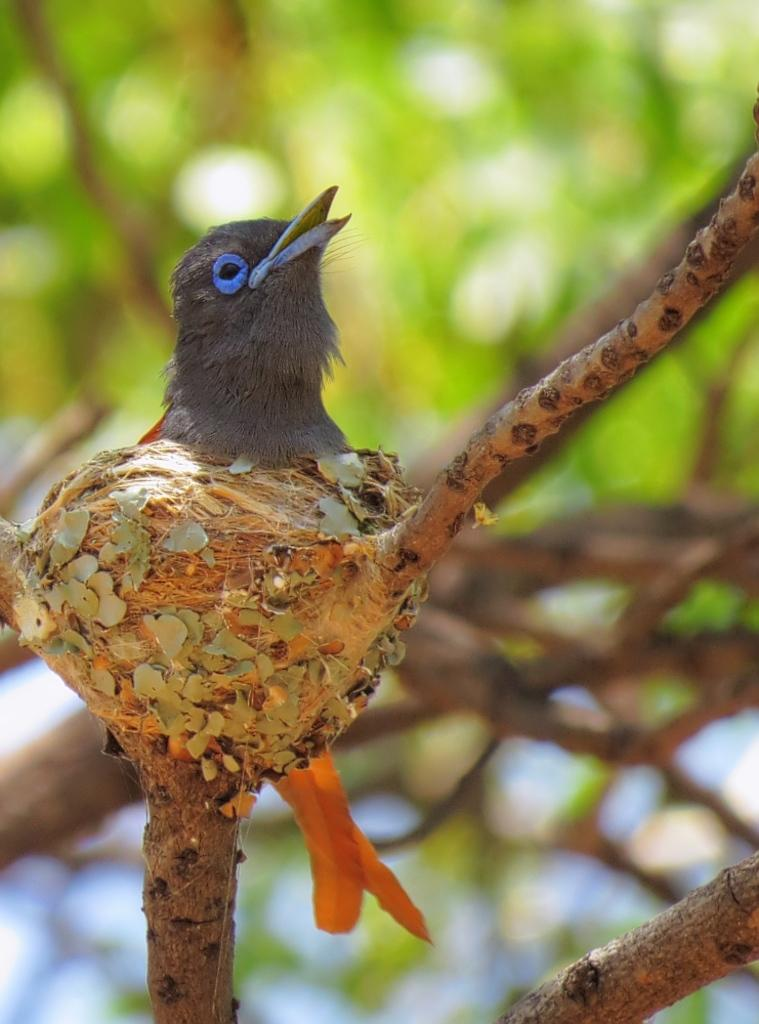What type of animal can be seen in the image? There is a bird in the image. What colors are present on the bird? The bird is black and orange in color. Where is the bird located in the image? The bird is on the branch of a tree. What is the color of the tree in the background? There is a green color tree in the background of the image. Is there a baby playing in the stream near the bird in the image? There is no baby or stream present in the image; it only features a bird on a tree branch and a green tree in the background. 